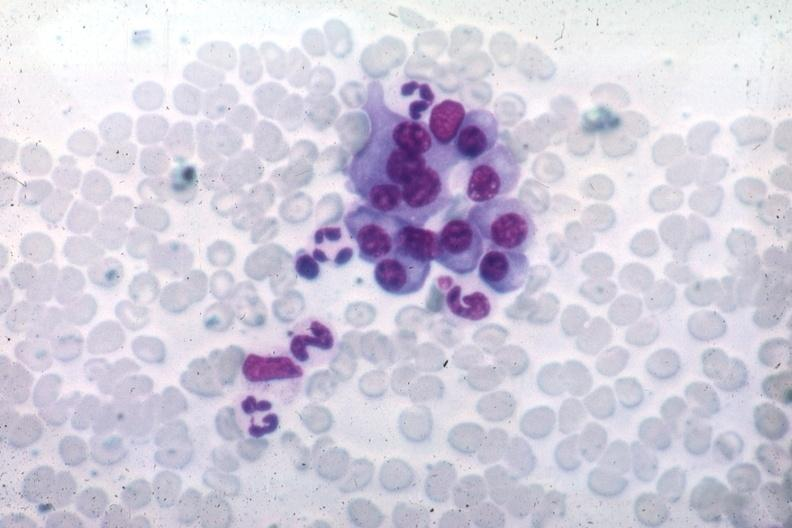what is present?
Answer the question using a single word or phrase. Bone marrow 